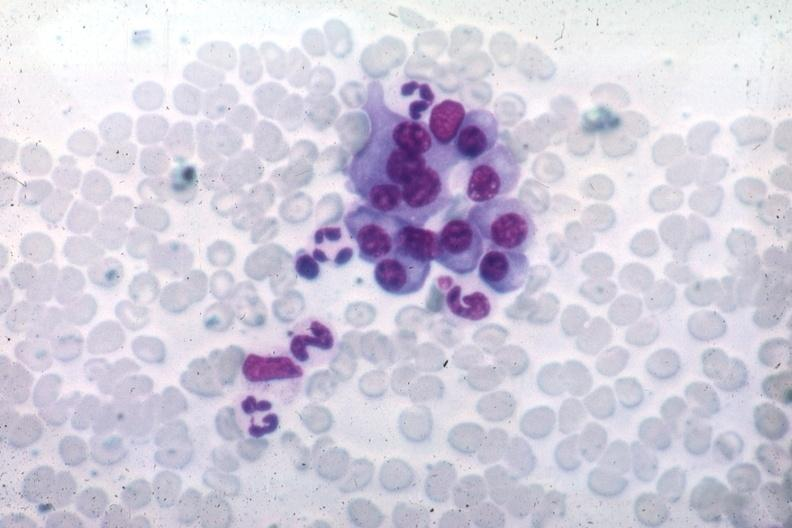what is present?
Answer the question using a single word or phrase. Bone marrow 